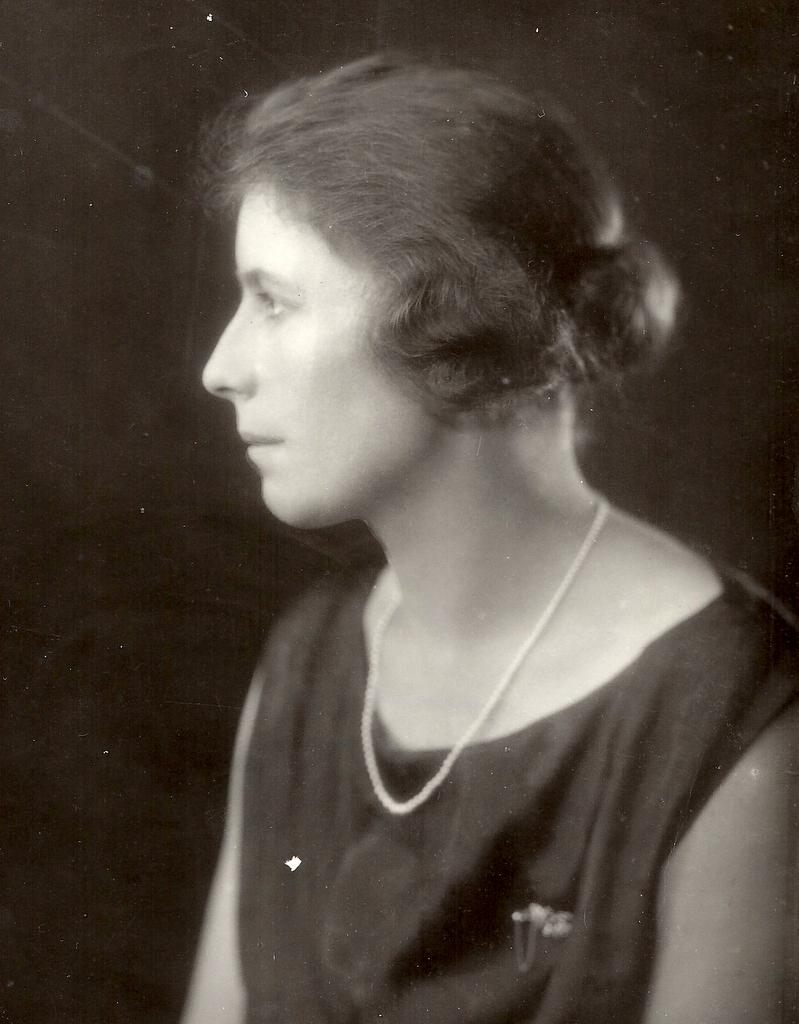What is the color scheme of the image? The image is black and white. Can you describe the main subject of the image? There is a woman in the image. What can be observed about the background of the image? The background of the image is dark. What type of stone is the woman holding in the image? There is no stone present in the image; it is a black and white image of a woman with a dark background. 